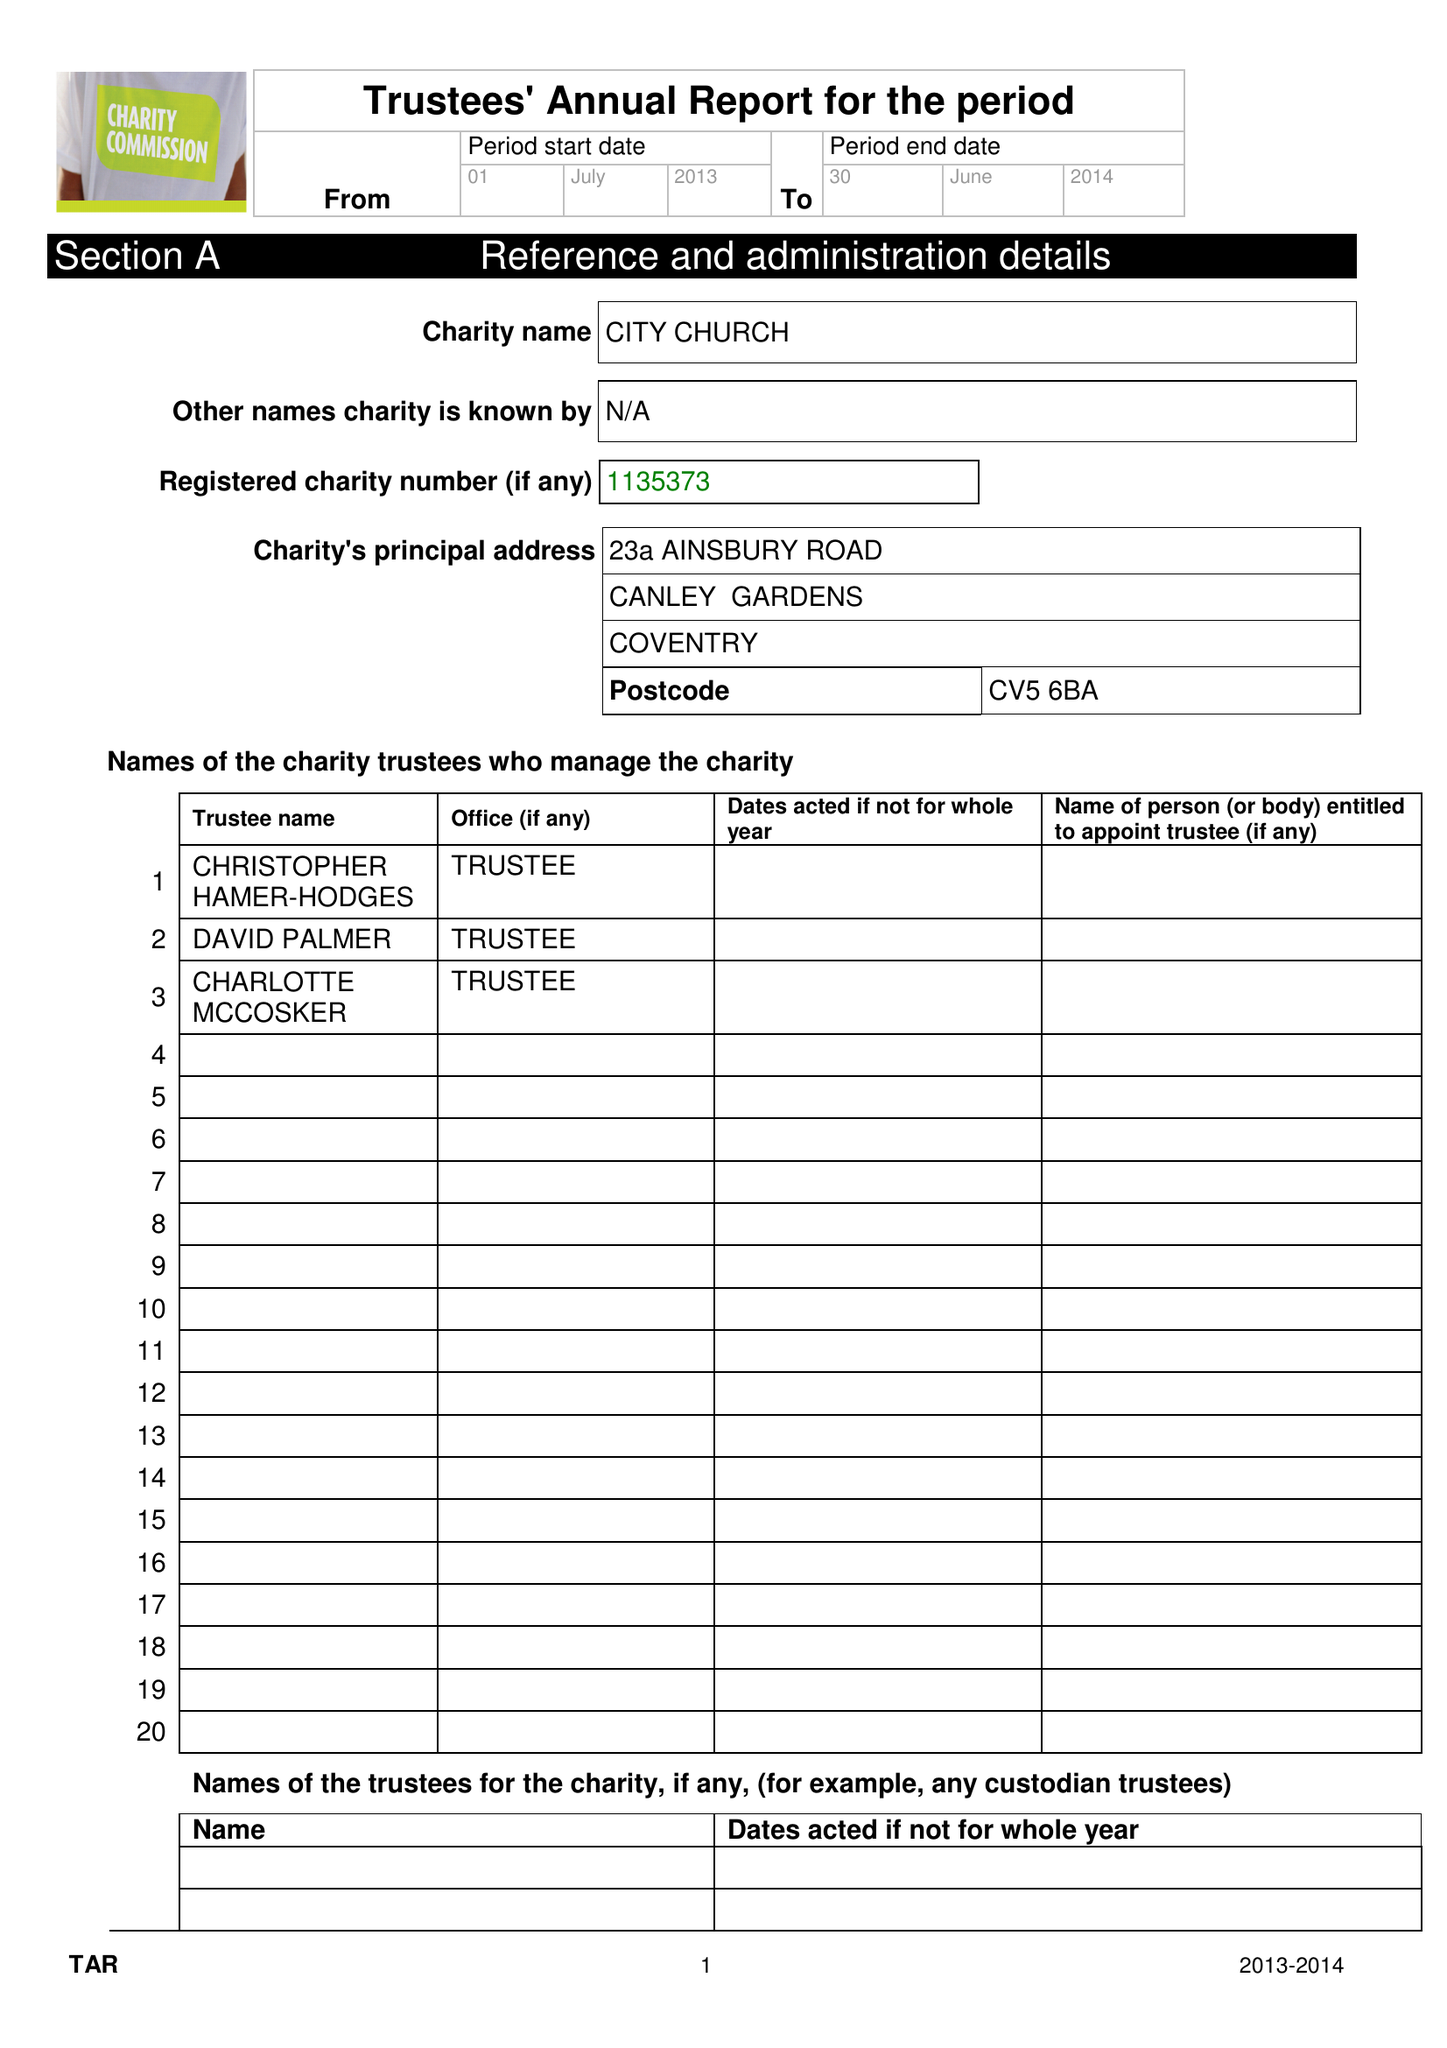What is the value for the spending_annually_in_british_pounds?
Answer the question using a single word or phrase. 94275.00 